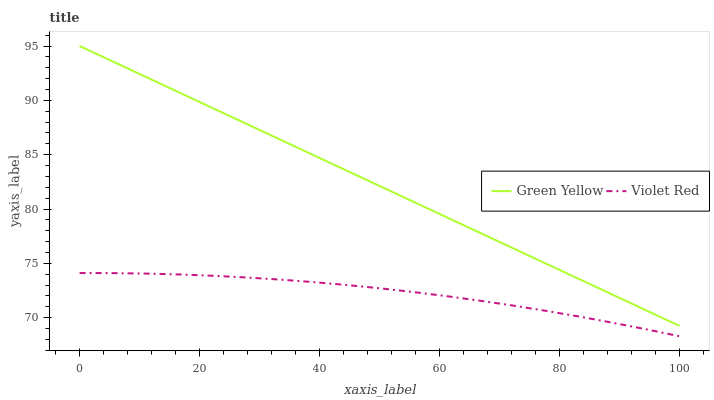Does Violet Red have the minimum area under the curve?
Answer yes or no. Yes. Does Green Yellow have the maximum area under the curve?
Answer yes or no. Yes. Does Green Yellow have the minimum area under the curve?
Answer yes or no. No. Is Green Yellow the smoothest?
Answer yes or no. Yes. Is Violet Red the roughest?
Answer yes or no. Yes. Is Green Yellow the roughest?
Answer yes or no. No. Does Violet Red have the lowest value?
Answer yes or no. Yes. Does Green Yellow have the lowest value?
Answer yes or no. No. Does Green Yellow have the highest value?
Answer yes or no. Yes. Is Violet Red less than Green Yellow?
Answer yes or no. Yes. Is Green Yellow greater than Violet Red?
Answer yes or no. Yes. Does Violet Red intersect Green Yellow?
Answer yes or no. No. 